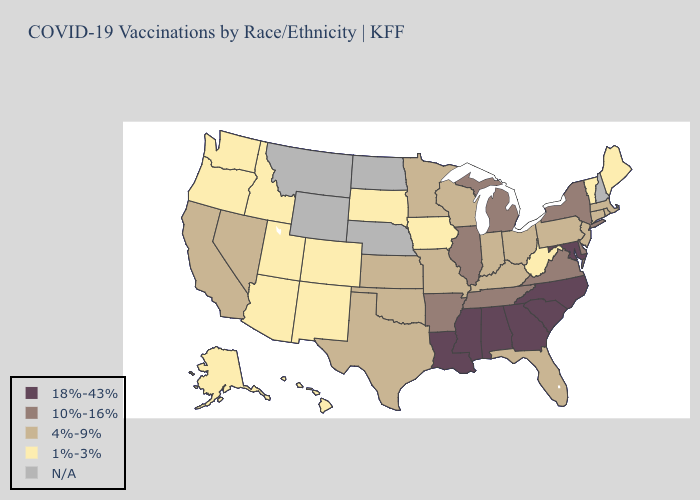What is the highest value in the USA?
Answer briefly. 18%-43%. What is the highest value in states that border Wisconsin?
Quick response, please. 10%-16%. What is the highest value in the USA?
Give a very brief answer. 18%-43%. Does California have the lowest value in the West?
Short answer required. No. What is the lowest value in the USA?
Quick response, please. 1%-3%. Name the states that have a value in the range 1%-3%?
Write a very short answer. Alaska, Arizona, Colorado, Hawaii, Idaho, Iowa, Maine, New Mexico, Oregon, South Dakota, Utah, Vermont, Washington, West Virginia. Name the states that have a value in the range 4%-9%?
Write a very short answer. California, Connecticut, Florida, Indiana, Kansas, Kentucky, Massachusetts, Minnesota, Missouri, Nevada, New Jersey, Ohio, Oklahoma, Pennsylvania, Rhode Island, Texas, Wisconsin. Among the states that border New Jersey , does Pennsylvania have the lowest value?
Concise answer only. Yes. What is the highest value in the USA?
Keep it brief. 18%-43%. Name the states that have a value in the range N/A?
Write a very short answer. Montana, Nebraska, New Hampshire, North Dakota, Wyoming. What is the value of New York?
Answer briefly. 10%-16%. Name the states that have a value in the range 1%-3%?
Keep it brief. Alaska, Arizona, Colorado, Hawaii, Idaho, Iowa, Maine, New Mexico, Oregon, South Dakota, Utah, Vermont, Washington, West Virginia. What is the value of Wisconsin?
Concise answer only. 4%-9%. Does the map have missing data?
Concise answer only. Yes. 